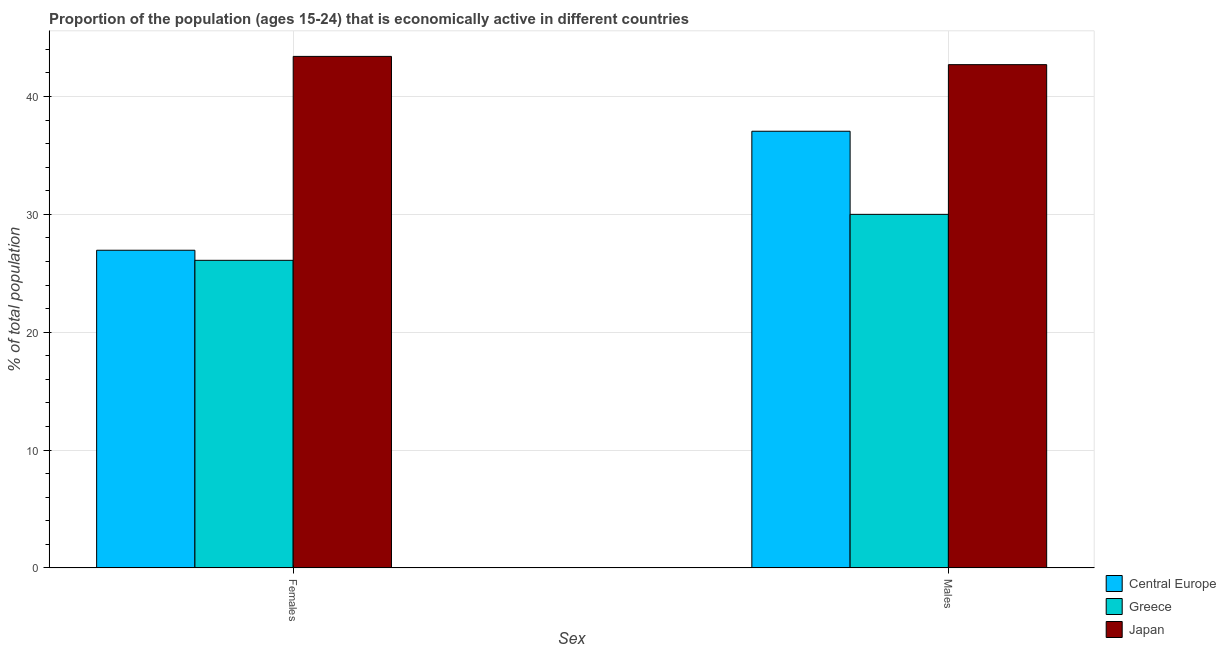How many different coloured bars are there?
Offer a terse response. 3. How many groups of bars are there?
Make the answer very short. 2. Are the number of bars on each tick of the X-axis equal?
Give a very brief answer. Yes. What is the label of the 2nd group of bars from the left?
Give a very brief answer. Males. What is the percentage of economically active female population in Japan?
Offer a terse response. 43.4. Across all countries, what is the maximum percentage of economically active male population?
Provide a short and direct response. 42.7. Across all countries, what is the minimum percentage of economically active female population?
Keep it short and to the point. 26.1. What is the total percentage of economically active male population in the graph?
Offer a very short reply. 109.75. What is the difference between the percentage of economically active female population in Central Europe and that in Japan?
Your answer should be very brief. -16.45. What is the difference between the percentage of economically active male population in Central Europe and the percentage of economically active female population in Greece?
Provide a short and direct response. 10.95. What is the average percentage of economically active female population per country?
Keep it short and to the point. 32.15. What is the difference between the percentage of economically active male population and percentage of economically active female population in Greece?
Make the answer very short. 3.9. In how many countries, is the percentage of economically active female population greater than 14 %?
Offer a terse response. 3. What is the ratio of the percentage of economically active female population in Greece to that in Central Europe?
Make the answer very short. 0.97. In how many countries, is the percentage of economically active male population greater than the average percentage of economically active male population taken over all countries?
Offer a terse response. 2. Are all the bars in the graph horizontal?
Give a very brief answer. No. How many countries are there in the graph?
Provide a succinct answer. 3. What is the difference between two consecutive major ticks on the Y-axis?
Your answer should be compact. 10. Are the values on the major ticks of Y-axis written in scientific E-notation?
Provide a succinct answer. No. Does the graph contain any zero values?
Provide a succinct answer. No. Does the graph contain grids?
Your answer should be compact. Yes. Where does the legend appear in the graph?
Provide a short and direct response. Bottom right. How are the legend labels stacked?
Ensure brevity in your answer.  Vertical. What is the title of the graph?
Your response must be concise. Proportion of the population (ages 15-24) that is economically active in different countries. What is the label or title of the X-axis?
Provide a short and direct response. Sex. What is the label or title of the Y-axis?
Your answer should be very brief. % of total population. What is the % of total population of Central Europe in Females?
Your response must be concise. 26.95. What is the % of total population in Greece in Females?
Provide a succinct answer. 26.1. What is the % of total population in Japan in Females?
Your answer should be compact. 43.4. What is the % of total population in Central Europe in Males?
Your response must be concise. 37.05. What is the % of total population in Greece in Males?
Your answer should be compact. 30. What is the % of total population of Japan in Males?
Make the answer very short. 42.7. Across all Sex, what is the maximum % of total population in Central Europe?
Keep it short and to the point. 37.05. Across all Sex, what is the maximum % of total population of Greece?
Provide a short and direct response. 30. Across all Sex, what is the maximum % of total population of Japan?
Offer a terse response. 43.4. Across all Sex, what is the minimum % of total population in Central Europe?
Provide a short and direct response. 26.95. Across all Sex, what is the minimum % of total population in Greece?
Provide a short and direct response. 26.1. Across all Sex, what is the minimum % of total population in Japan?
Give a very brief answer. 42.7. What is the total % of total population in Central Europe in the graph?
Ensure brevity in your answer.  64.01. What is the total % of total population of Greece in the graph?
Provide a short and direct response. 56.1. What is the total % of total population in Japan in the graph?
Offer a very short reply. 86.1. What is the difference between the % of total population of Central Europe in Females and that in Males?
Make the answer very short. -10.1. What is the difference between the % of total population in Greece in Females and that in Males?
Keep it short and to the point. -3.9. What is the difference between the % of total population of Japan in Females and that in Males?
Make the answer very short. 0.7. What is the difference between the % of total population in Central Europe in Females and the % of total population in Greece in Males?
Your answer should be compact. -3.05. What is the difference between the % of total population in Central Europe in Females and the % of total population in Japan in Males?
Your answer should be very brief. -15.75. What is the difference between the % of total population in Greece in Females and the % of total population in Japan in Males?
Keep it short and to the point. -16.6. What is the average % of total population of Central Europe per Sex?
Provide a short and direct response. 32. What is the average % of total population in Greece per Sex?
Offer a very short reply. 28.05. What is the average % of total population in Japan per Sex?
Offer a terse response. 43.05. What is the difference between the % of total population in Central Europe and % of total population in Greece in Females?
Keep it short and to the point. 0.85. What is the difference between the % of total population in Central Europe and % of total population in Japan in Females?
Make the answer very short. -16.45. What is the difference between the % of total population of Greece and % of total population of Japan in Females?
Your answer should be compact. -17.3. What is the difference between the % of total population of Central Europe and % of total population of Greece in Males?
Ensure brevity in your answer.  7.05. What is the difference between the % of total population in Central Europe and % of total population in Japan in Males?
Provide a short and direct response. -5.65. What is the ratio of the % of total population in Central Europe in Females to that in Males?
Offer a terse response. 0.73. What is the ratio of the % of total population of Greece in Females to that in Males?
Your answer should be compact. 0.87. What is the ratio of the % of total population in Japan in Females to that in Males?
Provide a succinct answer. 1.02. What is the difference between the highest and the second highest % of total population of Central Europe?
Make the answer very short. 10.1. What is the difference between the highest and the second highest % of total population in Greece?
Your answer should be compact. 3.9. What is the difference between the highest and the lowest % of total population in Central Europe?
Your answer should be very brief. 10.1. What is the difference between the highest and the lowest % of total population of Greece?
Keep it short and to the point. 3.9. What is the difference between the highest and the lowest % of total population in Japan?
Offer a terse response. 0.7. 